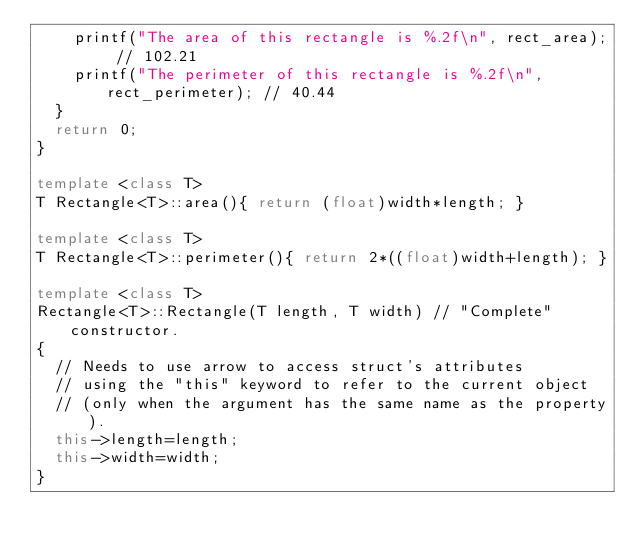Convert code to text. <code><loc_0><loc_0><loc_500><loc_500><_C++_>		printf("The area of this rectangle is %.2f\n", rect_area); // 102.21
		printf("The perimeter of this rectangle is %.2f\n", rect_perimeter); // 40.44
	}
	return 0;
}

template <class T>
T Rectangle<T>::area(){ return (float)width*length; }

template <class T>
T Rectangle<T>::perimeter(){ return 2*((float)width+length); }

template <class T>
Rectangle<T>::Rectangle(T length, T width) // "Complete" constructor.
{
	// Needs to use arrow to access struct's attributes
	// using the "this" keyword to refer to the current object
	// (only when the argument has the same name as the property).
	this->length=length;
	this->width=width;
}
</code> 